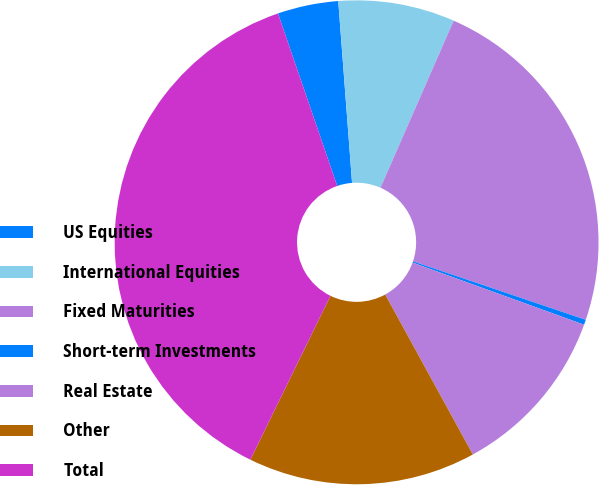Convert chart to OTSL. <chart><loc_0><loc_0><loc_500><loc_500><pie_chart><fcel>US Equities<fcel>International Equities<fcel>Fixed Maturities<fcel>Short-term Investments<fcel>Real Estate<fcel>Other<fcel>Total<nl><fcel>4.06%<fcel>7.78%<fcel>23.62%<fcel>0.34%<fcel>11.49%<fcel>15.21%<fcel>37.5%<nl></chart> 